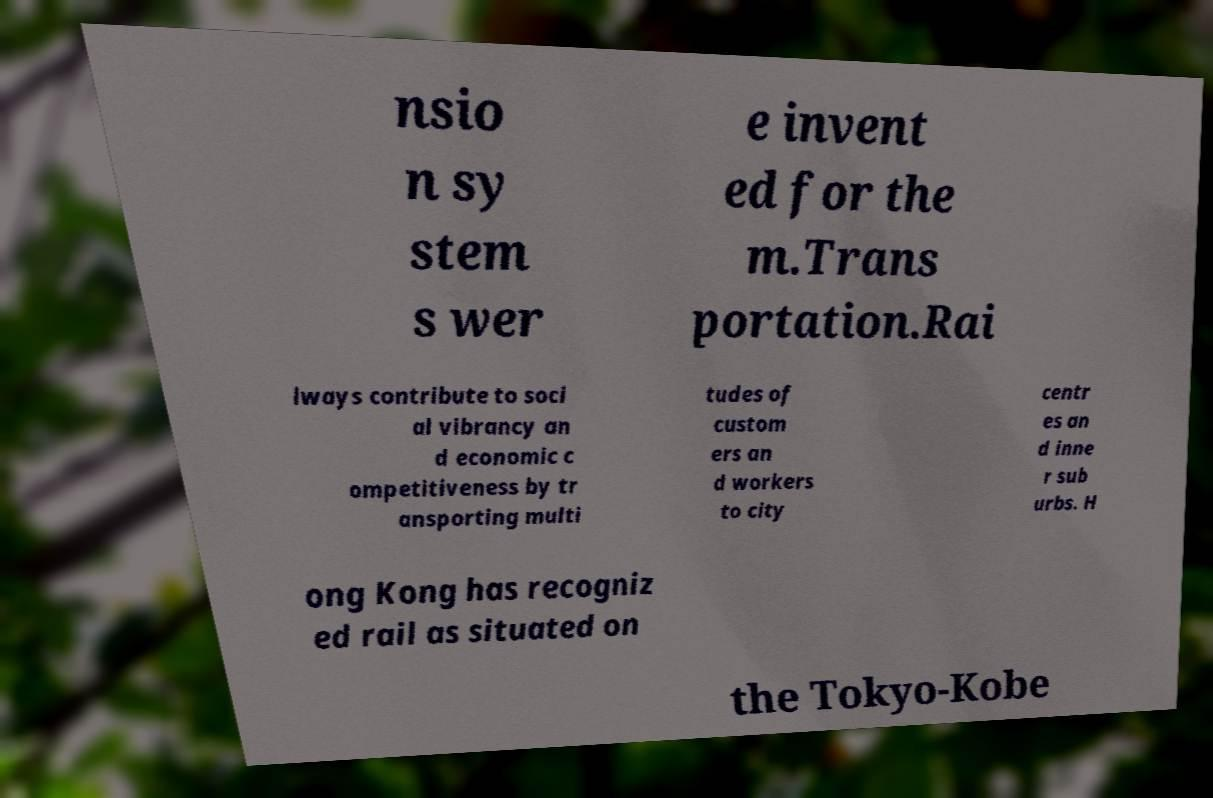Please identify and transcribe the text found in this image. nsio n sy stem s wer e invent ed for the m.Trans portation.Rai lways contribute to soci al vibrancy an d economic c ompetitiveness by tr ansporting multi tudes of custom ers an d workers to city centr es an d inne r sub urbs. H ong Kong has recogniz ed rail as situated on the Tokyo-Kobe 